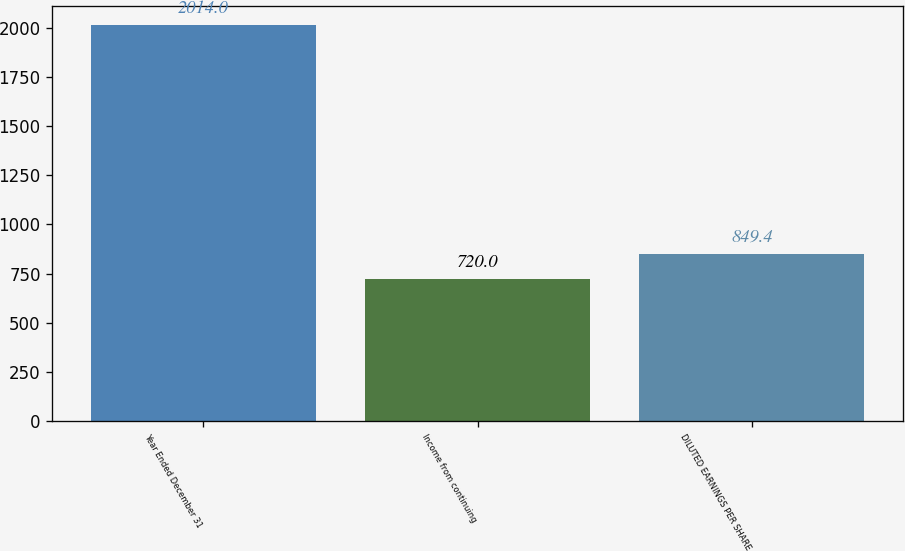Convert chart to OTSL. <chart><loc_0><loc_0><loc_500><loc_500><bar_chart><fcel>Year Ended December 31<fcel>Income from continuing<fcel>DILUTED EARNINGS PER SHARE<nl><fcel>2014<fcel>720<fcel>849.4<nl></chart> 